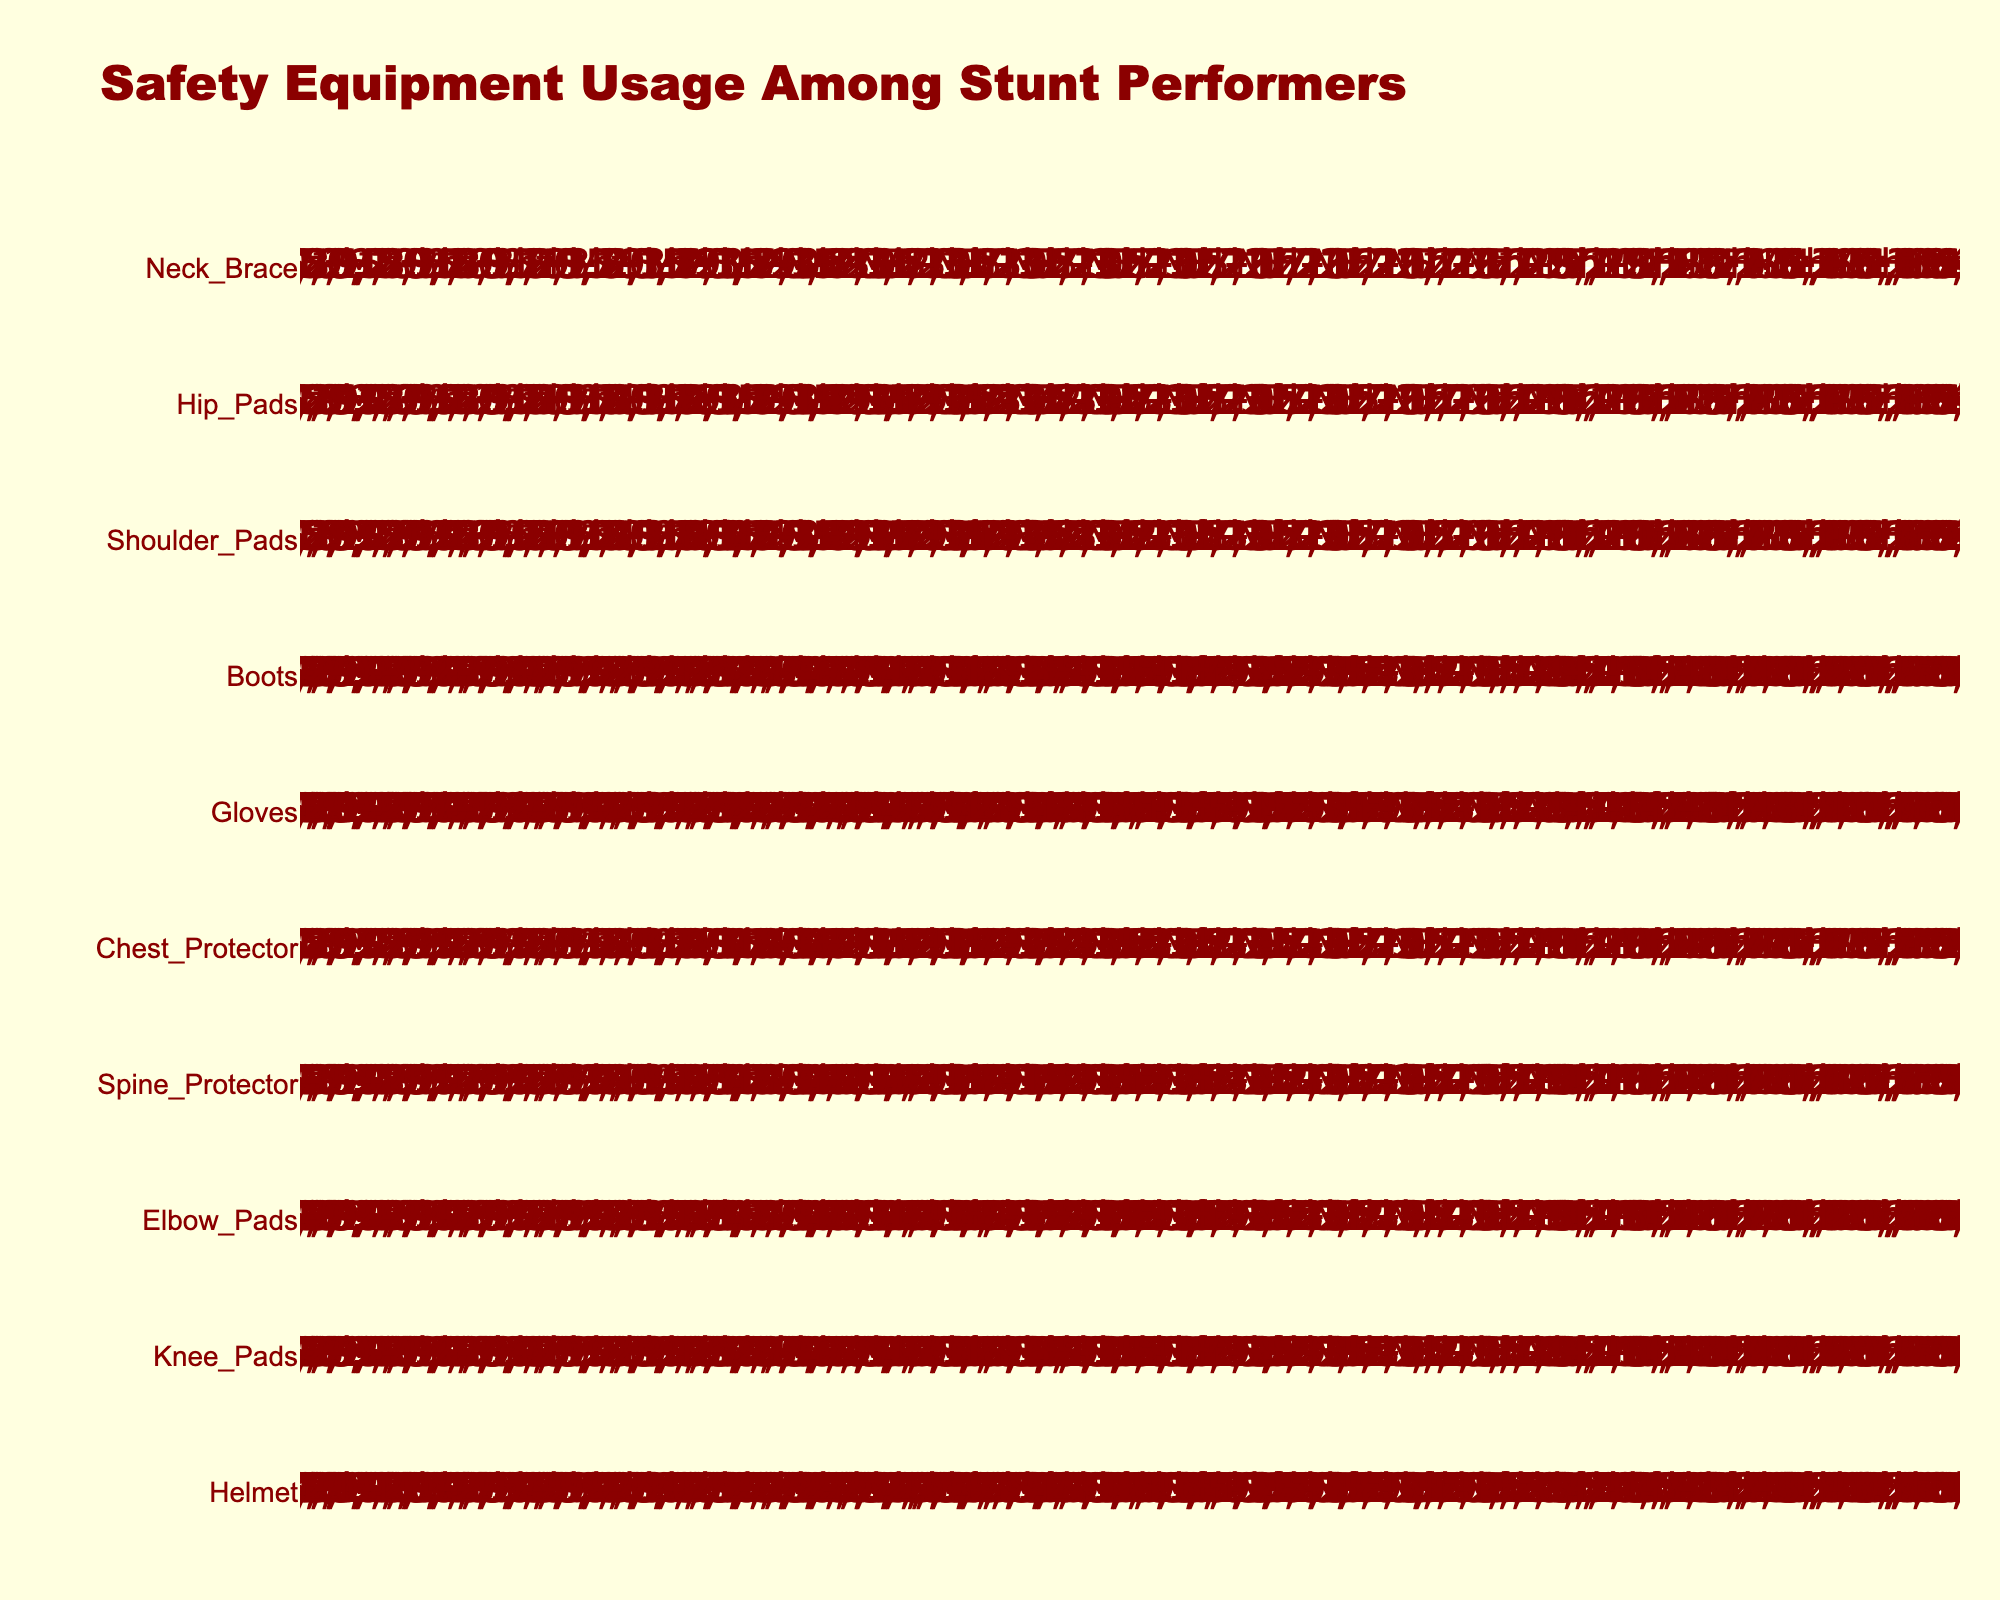How many different types of safety equipment are displayed in the figure? Count the number of distinct types of safety equipment listed on the y-axis.
Answer: 10 What's the title of the figure? Look at the large text at the top of the plot, it usually shows the title.
Answer: Safety Equipment Usage Among Stunt Performers Which safety equipment has the highest usage percentage? Identify the equipment with the most dark red icons, as it represents higher usage.
Answer: Helmet Which safety equipment has more usage: Knee Pads or Shoulder Pads? Compare the number of dark red icons for Knee Pads and Shoulder Pads.
Answer: Knee Pads What is the usage percentage of the Chest Protector? Find the Chest Protector label on the y-axis and read the percentage annotation next to it.
Answer: 70% Which equipment has the least usage? Identify the equipment with the fewest dark red icons, which represent lower usage.
Answer: Neck Brace What's the total percentage usage of Elbow Pads and Gloves combined? Add the usage percentages of Elbow Pads (80%) and Gloves (90%).
Answer: 170% Is the usage of Boots and Knee Pads the same or different? Compare the number of dark red icons for Boots and Knee Pads.
Answer: Same What color represents higher usage in the icons? Observe the color used for the greater part of each row of icons, which indicates higher usage.
Answer: Dark Red What is the average percentage usage of all the safety equipment? Sum all the usage percentages and divide by the number of equipment types (10). Calculation: (95 + 85 + 80 + 75 + 70 + 90 + 85 + 65 + 60 + 50) / 10 = 75
Answer: 75% 